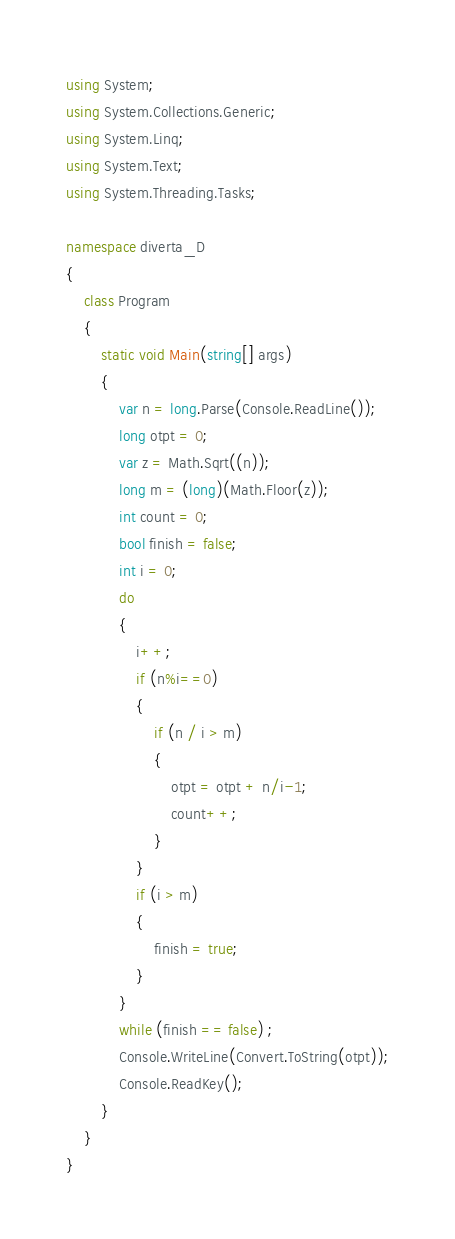Convert code to text. <code><loc_0><loc_0><loc_500><loc_500><_C#_>using System;
using System.Collections.Generic;
using System.Linq;
using System.Text;
using System.Threading.Tasks;

namespace diverta_D
{
    class Program
    {
        static void Main(string[] args)
        { 
            var n = long.Parse(Console.ReadLine());
            long otpt = 0;
            var z = Math.Sqrt((n));
            long m = (long)(Math.Floor(z));
            int count = 0;
            bool finish = false;
            int i = 0;
            do
            {
                i++;
                if (n%i==0)
                {
                    if (n / i > m)
                    {
                        otpt = otpt + n/i-1;
                        count++;
                    }
                }
                if (i > m)
                {
                    finish = true;
                }
            }
            while (finish == false) ;
            Console.WriteLine(Convert.ToString(otpt));
            Console.ReadKey();
        }
    }
}
</code> 